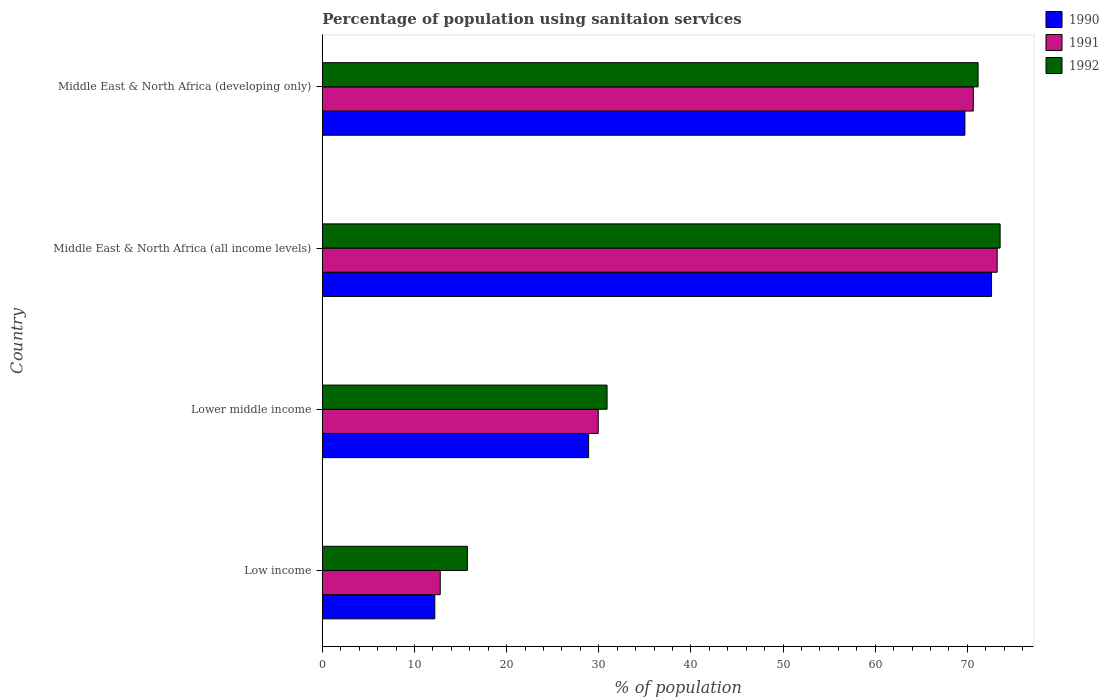How many different coloured bars are there?
Your response must be concise. 3. Are the number of bars per tick equal to the number of legend labels?
Keep it short and to the point. Yes. Are the number of bars on each tick of the Y-axis equal?
Ensure brevity in your answer.  Yes. How many bars are there on the 4th tick from the bottom?
Your response must be concise. 3. In how many cases, is the number of bars for a given country not equal to the number of legend labels?
Offer a terse response. 0. What is the percentage of population using sanitaion services in 1990 in Lower middle income?
Your response must be concise. 28.9. Across all countries, what is the maximum percentage of population using sanitaion services in 1991?
Provide a succinct answer. 73.24. Across all countries, what is the minimum percentage of population using sanitaion services in 1990?
Your answer should be compact. 12.21. In which country was the percentage of population using sanitaion services in 1991 maximum?
Provide a succinct answer. Middle East & North Africa (all income levels). In which country was the percentage of population using sanitaion services in 1991 minimum?
Make the answer very short. Low income. What is the total percentage of population using sanitaion services in 1990 in the graph?
Your answer should be very brief. 183.48. What is the difference between the percentage of population using sanitaion services in 1990 in Low income and that in Middle East & North Africa (developing only)?
Offer a terse response. -57.53. What is the difference between the percentage of population using sanitaion services in 1992 in Lower middle income and the percentage of population using sanitaion services in 1991 in Middle East & North Africa (developing only)?
Provide a short and direct response. -39.75. What is the average percentage of population using sanitaion services in 1992 per country?
Provide a short and direct response. 47.84. What is the difference between the percentage of population using sanitaion services in 1991 and percentage of population using sanitaion services in 1990 in Middle East & North Africa (all income levels)?
Provide a succinct answer. 0.61. In how many countries, is the percentage of population using sanitaion services in 1992 greater than 8 %?
Provide a succinct answer. 4. What is the ratio of the percentage of population using sanitaion services in 1990 in Lower middle income to that in Middle East & North Africa (all income levels)?
Keep it short and to the point. 0.4. Is the percentage of population using sanitaion services in 1992 in Low income less than that in Middle East & North Africa (developing only)?
Give a very brief answer. Yes. Is the difference between the percentage of population using sanitaion services in 1991 in Low income and Middle East & North Africa (all income levels) greater than the difference between the percentage of population using sanitaion services in 1990 in Low income and Middle East & North Africa (all income levels)?
Your answer should be compact. No. What is the difference between the highest and the second highest percentage of population using sanitaion services in 1990?
Your response must be concise. 2.89. What is the difference between the highest and the lowest percentage of population using sanitaion services in 1990?
Provide a succinct answer. 60.42. Is the sum of the percentage of population using sanitaion services in 1991 in Middle East & North Africa (all income levels) and Middle East & North Africa (developing only) greater than the maximum percentage of population using sanitaion services in 1990 across all countries?
Provide a succinct answer. Yes. Does the graph contain grids?
Keep it short and to the point. No. How many legend labels are there?
Provide a short and direct response. 3. How are the legend labels stacked?
Ensure brevity in your answer.  Vertical. What is the title of the graph?
Your answer should be compact. Percentage of population using sanitaion services. What is the label or title of the X-axis?
Your answer should be very brief. % of population. What is the label or title of the Y-axis?
Your answer should be compact. Country. What is the % of population of 1990 in Low income?
Keep it short and to the point. 12.21. What is the % of population in 1991 in Low income?
Offer a terse response. 12.8. What is the % of population of 1992 in Low income?
Your answer should be compact. 15.74. What is the % of population in 1990 in Lower middle income?
Your answer should be compact. 28.9. What is the % of population of 1991 in Lower middle income?
Give a very brief answer. 29.95. What is the % of population in 1992 in Lower middle income?
Your answer should be very brief. 30.9. What is the % of population in 1990 in Middle East & North Africa (all income levels)?
Ensure brevity in your answer.  72.63. What is the % of population of 1991 in Middle East & North Africa (all income levels)?
Your answer should be very brief. 73.24. What is the % of population in 1992 in Middle East & North Africa (all income levels)?
Ensure brevity in your answer.  73.56. What is the % of population in 1990 in Middle East & North Africa (developing only)?
Your response must be concise. 69.74. What is the % of population in 1991 in Middle East & North Africa (developing only)?
Ensure brevity in your answer.  70.65. What is the % of population of 1992 in Middle East & North Africa (developing only)?
Ensure brevity in your answer.  71.17. Across all countries, what is the maximum % of population in 1990?
Offer a terse response. 72.63. Across all countries, what is the maximum % of population in 1991?
Offer a very short reply. 73.24. Across all countries, what is the maximum % of population in 1992?
Offer a terse response. 73.56. Across all countries, what is the minimum % of population in 1990?
Make the answer very short. 12.21. Across all countries, what is the minimum % of population of 1991?
Offer a very short reply. 12.8. Across all countries, what is the minimum % of population in 1992?
Keep it short and to the point. 15.74. What is the total % of population in 1990 in the graph?
Offer a very short reply. 183.48. What is the total % of population of 1991 in the graph?
Your answer should be very brief. 186.64. What is the total % of population in 1992 in the graph?
Keep it short and to the point. 191.37. What is the difference between the % of population of 1990 in Low income and that in Lower middle income?
Ensure brevity in your answer.  -16.69. What is the difference between the % of population of 1991 in Low income and that in Lower middle income?
Your response must be concise. -17.15. What is the difference between the % of population of 1992 in Low income and that in Lower middle income?
Your answer should be compact. -15.16. What is the difference between the % of population in 1990 in Low income and that in Middle East & North Africa (all income levels)?
Provide a succinct answer. -60.42. What is the difference between the % of population in 1991 in Low income and that in Middle East & North Africa (all income levels)?
Ensure brevity in your answer.  -60.45. What is the difference between the % of population of 1992 in Low income and that in Middle East & North Africa (all income levels)?
Offer a terse response. -57.82. What is the difference between the % of population of 1990 in Low income and that in Middle East & North Africa (developing only)?
Give a very brief answer. -57.53. What is the difference between the % of population of 1991 in Low income and that in Middle East & North Africa (developing only)?
Your answer should be very brief. -57.86. What is the difference between the % of population of 1992 in Low income and that in Middle East & North Africa (developing only)?
Make the answer very short. -55.43. What is the difference between the % of population of 1990 in Lower middle income and that in Middle East & North Africa (all income levels)?
Offer a very short reply. -43.73. What is the difference between the % of population in 1991 in Lower middle income and that in Middle East & North Africa (all income levels)?
Offer a terse response. -43.3. What is the difference between the % of population in 1992 in Lower middle income and that in Middle East & North Africa (all income levels)?
Provide a succinct answer. -42.66. What is the difference between the % of population in 1990 in Lower middle income and that in Middle East & North Africa (developing only)?
Provide a succinct answer. -40.84. What is the difference between the % of population in 1991 in Lower middle income and that in Middle East & North Africa (developing only)?
Offer a very short reply. -40.71. What is the difference between the % of population in 1992 in Lower middle income and that in Middle East & North Africa (developing only)?
Your response must be concise. -40.27. What is the difference between the % of population of 1990 in Middle East & North Africa (all income levels) and that in Middle East & North Africa (developing only)?
Provide a succinct answer. 2.89. What is the difference between the % of population of 1991 in Middle East & North Africa (all income levels) and that in Middle East & North Africa (developing only)?
Your response must be concise. 2.59. What is the difference between the % of population of 1992 in Middle East & North Africa (all income levels) and that in Middle East & North Africa (developing only)?
Keep it short and to the point. 2.39. What is the difference between the % of population of 1990 in Low income and the % of population of 1991 in Lower middle income?
Your answer should be compact. -17.74. What is the difference between the % of population of 1990 in Low income and the % of population of 1992 in Lower middle income?
Offer a very short reply. -18.69. What is the difference between the % of population of 1991 in Low income and the % of population of 1992 in Lower middle income?
Give a very brief answer. -18.11. What is the difference between the % of population of 1990 in Low income and the % of population of 1991 in Middle East & North Africa (all income levels)?
Ensure brevity in your answer.  -61.03. What is the difference between the % of population of 1990 in Low income and the % of population of 1992 in Middle East & North Africa (all income levels)?
Make the answer very short. -61.35. What is the difference between the % of population of 1991 in Low income and the % of population of 1992 in Middle East & North Africa (all income levels)?
Keep it short and to the point. -60.76. What is the difference between the % of population in 1990 in Low income and the % of population in 1991 in Middle East & North Africa (developing only)?
Your answer should be very brief. -58.45. What is the difference between the % of population of 1990 in Low income and the % of population of 1992 in Middle East & North Africa (developing only)?
Your answer should be compact. -58.96. What is the difference between the % of population in 1991 in Low income and the % of population in 1992 in Middle East & North Africa (developing only)?
Make the answer very short. -58.37. What is the difference between the % of population of 1990 in Lower middle income and the % of population of 1991 in Middle East & North Africa (all income levels)?
Make the answer very short. -44.34. What is the difference between the % of population in 1990 in Lower middle income and the % of population in 1992 in Middle East & North Africa (all income levels)?
Your answer should be very brief. -44.66. What is the difference between the % of population of 1991 in Lower middle income and the % of population of 1992 in Middle East & North Africa (all income levels)?
Your answer should be very brief. -43.62. What is the difference between the % of population in 1990 in Lower middle income and the % of population in 1991 in Middle East & North Africa (developing only)?
Your response must be concise. -41.75. What is the difference between the % of population of 1990 in Lower middle income and the % of population of 1992 in Middle East & North Africa (developing only)?
Give a very brief answer. -42.27. What is the difference between the % of population in 1991 in Lower middle income and the % of population in 1992 in Middle East & North Africa (developing only)?
Your response must be concise. -41.23. What is the difference between the % of population in 1990 in Middle East & North Africa (all income levels) and the % of population in 1991 in Middle East & North Africa (developing only)?
Give a very brief answer. 1.98. What is the difference between the % of population of 1990 in Middle East & North Africa (all income levels) and the % of population of 1992 in Middle East & North Africa (developing only)?
Make the answer very short. 1.46. What is the difference between the % of population of 1991 in Middle East & North Africa (all income levels) and the % of population of 1992 in Middle East & North Africa (developing only)?
Provide a succinct answer. 2.07. What is the average % of population in 1990 per country?
Your response must be concise. 45.87. What is the average % of population of 1991 per country?
Your response must be concise. 46.66. What is the average % of population of 1992 per country?
Provide a short and direct response. 47.84. What is the difference between the % of population of 1990 and % of population of 1991 in Low income?
Keep it short and to the point. -0.59. What is the difference between the % of population of 1990 and % of population of 1992 in Low income?
Provide a succinct answer. -3.53. What is the difference between the % of population in 1991 and % of population in 1992 in Low income?
Make the answer very short. -2.94. What is the difference between the % of population of 1990 and % of population of 1991 in Lower middle income?
Provide a succinct answer. -1.04. What is the difference between the % of population in 1990 and % of population in 1992 in Lower middle income?
Ensure brevity in your answer.  -2. What is the difference between the % of population in 1991 and % of population in 1992 in Lower middle income?
Offer a terse response. -0.96. What is the difference between the % of population in 1990 and % of population in 1991 in Middle East & North Africa (all income levels)?
Provide a succinct answer. -0.61. What is the difference between the % of population of 1990 and % of population of 1992 in Middle East & North Africa (all income levels)?
Give a very brief answer. -0.93. What is the difference between the % of population in 1991 and % of population in 1992 in Middle East & North Africa (all income levels)?
Offer a terse response. -0.32. What is the difference between the % of population of 1990 and % of population of 1991 in Middle East & North Africa (developing only)?
Offer a very short reply. -0.91. What is the difference between the % of population of 1990 and % of population of 1992 in Middle East & North Africa (developing only)?
Give a very brief answer. -1.43. What is the difference between the % of population of 1991 and % of population of 1992 in Middle East & North Africa (developing only)?
Provide a succinct answer. -0.52. What is the ratio of the % of population of 1990 in Low income to that in Lower middle income?
Ensure brevity in your answer.  0.42. What is the ratio of the % of population of 1991 in Low income to that in Lower middle income?
Ensure brevity in your answer.  0.43. What is the ratio of the % of population of 1992 in Low income to that in Lower middle income?
Your answer should be very brief. 0.51. What is the ratio of the % of population of 1990 in Low income to that in Middle East & North Africa (all income levels)?
Your answer should be compact. 0.17. What is the ratio of the % of population of 1991 in Low income to that in Middle East & North Africa (all income levels)?
Your response must be concise. 0.17. What is the ratio of the % of population in 1992 in Low income to that in Middle East & North Africa (all income levels)?
Your response must be concise. 0.21. What is the ratio of the % of population in 1990 in Low income to that in Middle East & North Africa (developing only)?
Offer a very short reply. 0.18. What is the ratio of the % of population of 1991 in Low income to that in Middle East & North Africa (developing only)?
Your response must be concise. 0.18. What is the ratio of the % of population in 1992 in Low income to that in Middle East & North Africa (developing only)?
Ensure brevity in your answer.  0.22. What is the ratio of the % of population in 1990 in Lower middle income to that in Middle East & North Africa (all income levels)?
Keep it short and to the point. 0.4. What is the ratio of the % of population in 1991 in Lower middle income to that in Middle East & North Africa (all income levels)?
Keep it short and to the point. 0.41. What is the ratio of the % of population of 1992 in Lower middle income to that in Middle East & North Africa (all income levels)?
Offer a very short reply. 0.42. What is the ratio of the % of population in 1990 in Lower middle income to that in Middle East & North Africa (developing only)?
Ensure brevity in your answer.  0.41. What is the ratio of the % of population in 1991 in Lower middle income to that in Middle East & North Africa (developing only)?
Offer a very short reply. 0.42. What is the ratio of the % of population of 1992 in Lower middle income to that in Middle East & North Africa (developing only)?
Provide a short and direct response. 0.43. What is the ratio of the % of population of 1990 in Middle East & North Africa (all income levels) to that in Middle East & North Africa (developing only)?
Offer a terse response. 1.04. What is the ratio of the % of population in 1991 in Middle East & North Africa (all income levels) to that in Middle East & North Africa (developing only)?
Keep it short and to the point. 1.04. What is the ratio of the % of population in 1992 in Middle East & North Africa (all income levels) to that in Middle East & North Africa (developing only)?
Make the answer very short. 1.03. What is the difference between the highest and the second highest % of population in 1990?
Give a very brief answer. 2.89. What is the difference between the highest and the second highest % of population in 1991?
Provide a short and direct response. 2.59. What is the difference between the highest and the second highest % of population in 1992?
Make the answer very short. 2.39. What is the difference between the highest and the lowest % of population in 1990?
Keep it short and to the point. 60.42. What is the difference between the highest and the lowest % of population of 1991?
Make the answer very short. 60.45. What is the difference between the highest and the lowest % of population in 1992?
Your answer should be compact. 57.82. 